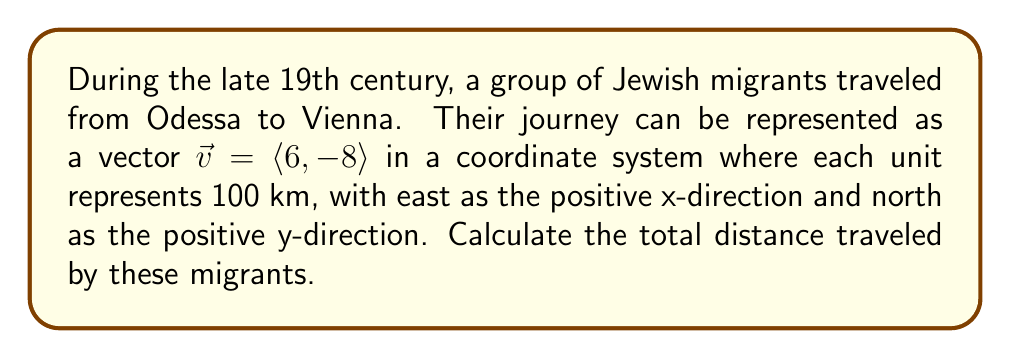Can you answer this question? To find the total distance traveled, we need to calculate the magnitude of the vector $\vec{v} = \langle 6, -8 \rangle$. This can be done using the Pythagorean theorem:

1) The magnitude of a vector $\vec{v} = \langle a, b \rangle$ is given by:
   $$|\vec{v}| = \sqrt{a^2 + b^2}$$

2) Substituting our values:
   $$|\vec{v}| = \sqrt{6^2 + (-8)^2}$$

3) Simplify:
   $$|\vec{v}| = \sqrt{36 + 64}$$
   $$|\vec{v}| = \sqrt{100}$$

4) Simplify the square root:
   $$|\vec{v}| = 10$$

5) Since each unit represents 100 km, multiply the result by 100:
   $$\text{Total distance} = 10 \times 100 = 1000 \text{ km}$$

Therefore, the Jewish migrants traveled a total distance of 1000 km from Odessa to Vienna.
Answer: 1000 km 